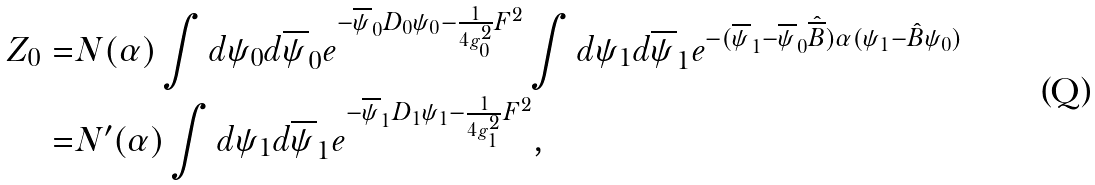<formula> <loc_0><loc_0><loc_500><loc_500>Z _ { 0 } = & N ( \alpha ) \int d \psi _ { 0 } d \overline { \psi } _ { 0 } e ^ { - \overline { \psi } _ { 0 } D _ { 0 } \psi _ { 0 } - \frac { 1 } { 4 g _ { 0 } ^ { 2 } } F ^ { 2 } } \int d \psi _ { 1 } d \overline { \psi } _ { 1 } e ^ { - ( \overline { \psi } _ { 1 } - \overline { \psi } _ { 0 } \hat { \overline { B } } ) \alpha ( \psi _ { 1 } - \hat { B } \psi _ { 0 } ) } \\ = & N ^ { \prime } ( \alpha ) \int d \psi _ { 1 } d \overline { \psi } _ { 1 } e ^ { - \overline { \psi } _ { 1 } D _ { 1 } \psi _ { 1 } - \frac { 1 } { 4 g _ { 1 } ^ { 2 } } F ^ { 2 } } ,</formula> 